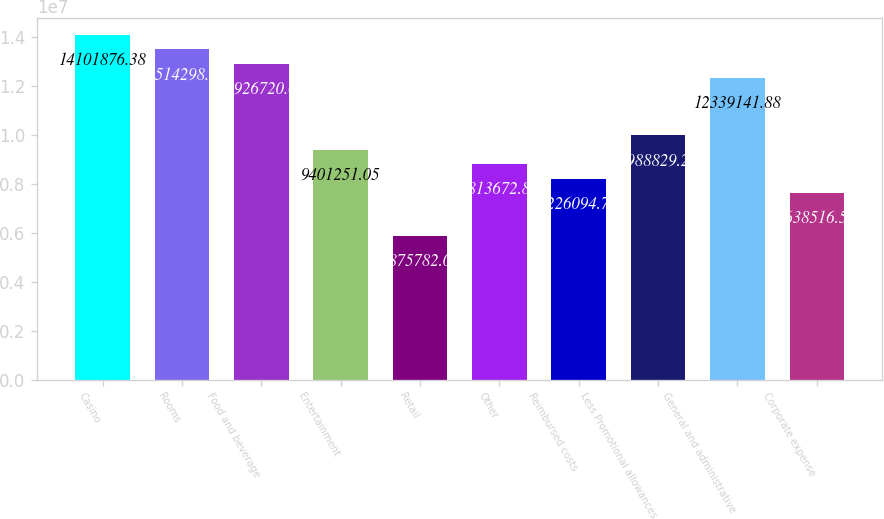Convert chart to OTSL. <chart><loc_0><loc_0><loc_500><loc_500><bar_chart><fcel>Casino<fcel>Rooms<fcel>Food and beverage<fcel>Entertainment<fcel>Retail<fcel>Other<fcel>Reimbursed costs<fcel>Less Promotional allowances<fcel>General and administrative<fcel>Corporate expense<nl><fcel>1.41019e+07<fcel>1.35143e+07<fcel>1.29267e+07<fcel>9.40125e+06<fcel>5.87578e+06<fcel>8.81367e+06<fcel>8.22609e+06<fcel>9.98883e+06<fcel>1.23391e+07<fcel>7.63852e+06<nl></chart> 